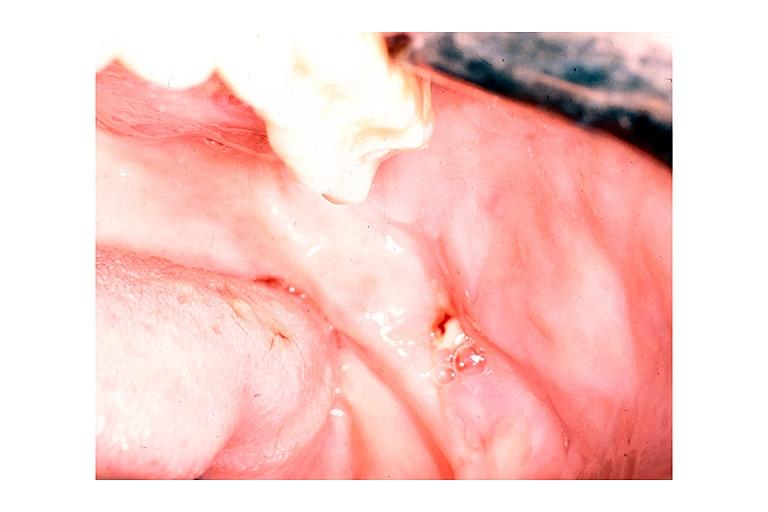what does this image show?
Answer the question using a single word or phrase. Chronic osteomyelitis 